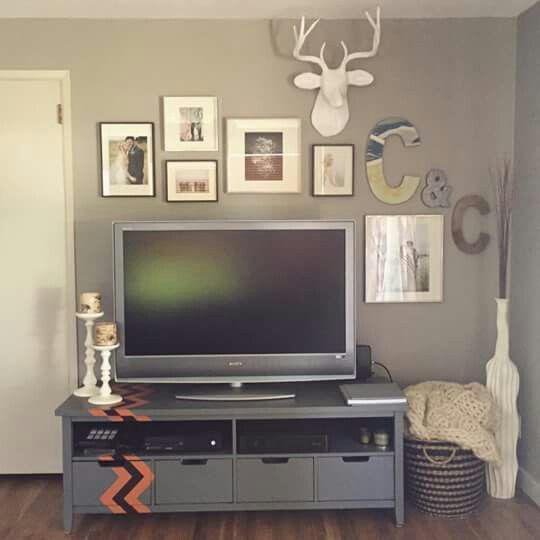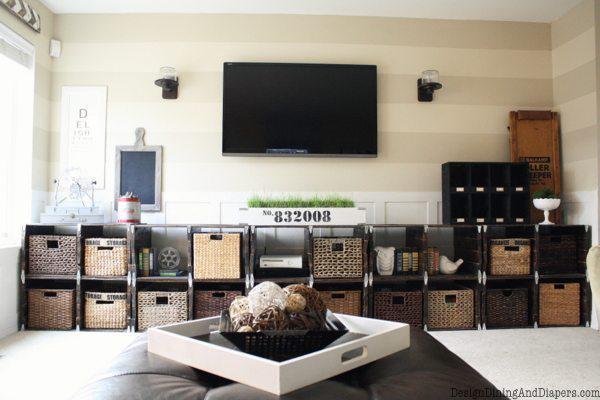The first image is the image on the left, the second image is the image on the right. Examine the images to the left and right. Is the description "There is a least one individual letter hanging near a TV." accurate? Answer yes or no. Yes. The first image is the image on the left, the second image is the image on the right. For the images shown, is this caption "there is at least one clock on the wall behind the tv" true? Answer yes or no. No. 